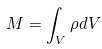<formula> <loc_0><loc_0><loc_500><loc_500>M = \int _ { V } \rho d V</formula> 